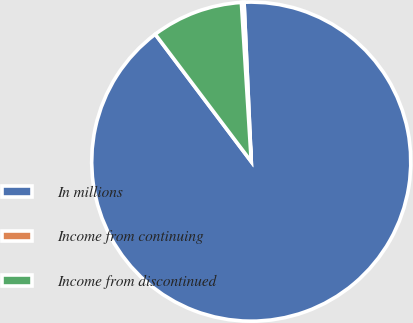Convert chart. <chart><loc_0><loc_0><loc_500><loc_500><pie_chart><fcel>In millions<fcel>Income from continuing<fcel>Income from discontinued<nl><fcel>90.44%<fcel>0.27%<fcel>9.29%<nl></chart> 